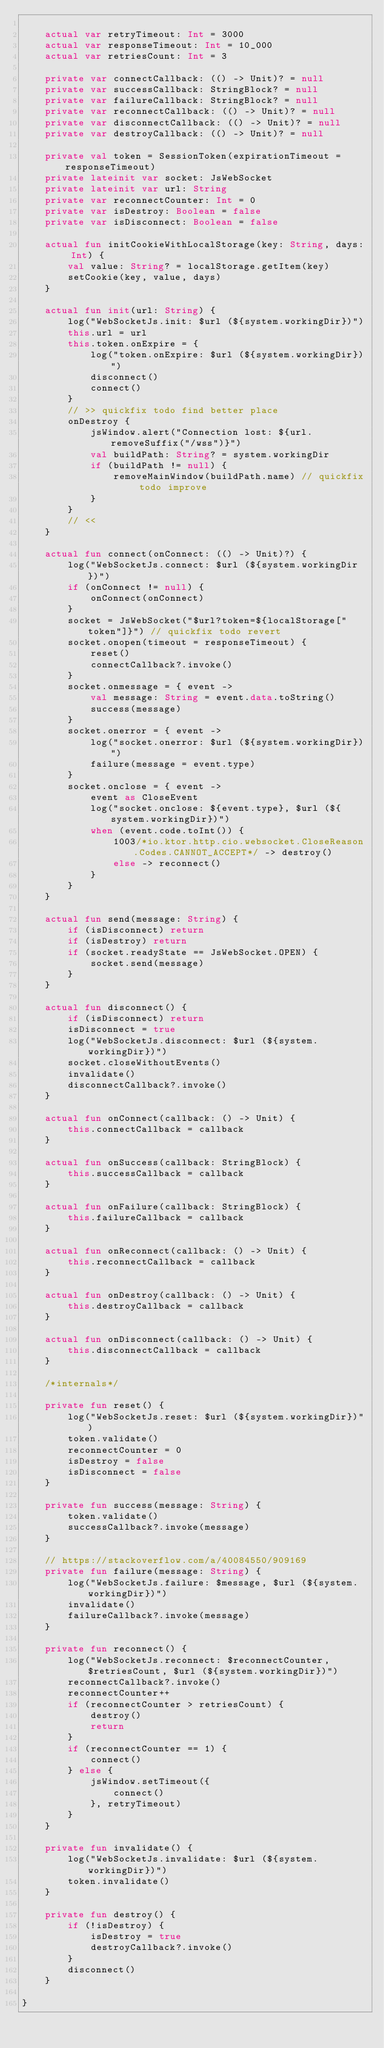<code> <loc_0><loc_0><loc_500><loc_500><_Kotlin_>
    actual var retryTimeout: Int = 3000
    actual var responseTimeout: Int = 10_000
    actual var retriesCount: Int = 3

    private var connectCallback: (() -> Unit)? = null
    private var successCallback: StringBlock? = null
    private var failureCallback: StringBlock? = null
    private var reconnectCallback: (() -> Unit)? = null
    private var disconnectCallback: (() -> Unit)? = null
    private var destroyCallback: (() -> Unit)? = null

    private val token = SessionToken(expirationTimeout = responseTimeout)
    private lateinit var socket: JsWebSocket
    private lateinit var url: String
    private var reconnectCounter: Int = 0
    private var isDestroy: Boolean = false
    private var isDisconnect: Boolean = false

    actual fun initCookieWithLocalStorage(key: String, days: Int) {
        val value: String? = localStorage.getItem(key)
        setCookie(key, value, days)
    }

    actual fun init(url: String) {
        log("WebSocketJs.init: $url (${system.workingDir})")
        this.url = url
        this.token.onExpire = {
            log("token.onExpire: $url (${system.workingDir})")
            disconnect()
            connect()
        }
        // >> quickfix todo find better place
        onDestroy {
            jsWindow.alert("Connection lost: ${url.removeSuffix("/wss")}")
            val buildPath: String? = system.workingDir
            if (buildPath != null) {
                removeMainWindow(buildPath.name) // quickfix todo improve
            }
        }
        // <<
    }

    actual fun connect(onConnect: (() -> Unit)?) {
        log("WebSocketJs.connect: $url (${system.workingDir})")
        if (onConnect != null) {
            onConnect(onConnect)
        }
        socket = JsWebSocket("$url?token=${localStorage["token"]}") // quickfix todo revert
        socket.onopen(timeout = responseTimeout) {
            reset()
            connectCallback?.invoke()
        }
        socket.onmessage = { event ->
            val message: String = event.data.toString()
            success(message)
        }
        socket.onerror = { event ->
            log("socket.onerror: $url (${system.workingDir})")
            failure(message = event.type)
        }
        socket.onclose = { event ->
            event as CloseEvent
            log("socket.onclose: ${event.type}, $url (${system.workingDir})")
            when (event.code.toInt()) {
                1003/*io.ktor.http.cio.websocket.CloseReason.Codes.CANNOT_ACCEPT*/ -> destroy()
                else -> reconnect()
            }
        }
    }

    actual fun send(message: String) {
        if (isDisconnect) return
        if (isDestroy) return
        if (socket.readyState == JsWebSocket.OPEN) {
            socket.send(message)
        }
    }

    actual fun disconnect() {
        if (isDisconnect) return
        isDisconnect = true
        log("WebSocketJs.disconnect: $url (${system.workingDir})")
        socket.closeWithoutEvents()
        invalidate()
        disconnectCallback?.invoke()
    }

    actual fun onConnect(callback: () -> Unit) {
        this.connectCallback = callback
    }

    actual fun onSuccess(callback: StringBlock) {
        this.successCallback = callback
    }

    actual fun onFailure(callback: StringBlock) {
        this.failureCallback = callback
    }

    actual fun onReconnect(callback: () -> Unit) {
        this.reconnectCallback = callback
    }

    actual fun onDestroy(callback: () -> Unit) {
        this.destroyCallback = callback
    }

    actual fun onDisconnect(callback: () -> Unit) {
        this.disconnectCallback = callback
    }

    /*internals*/

    private fun reset() {
        log("WebSocketJs.reset: $url (${system.workingDir})")
        token.validate()
        reconnectCounter = 0
        isDestroy = false
        isDisconnect = false
    }

    private fun success(message: String) {
        token.validate()
        successCallback?.invoke(message)
    }

    // https://stackoverflow.com/a/40084550/909169
    private fun failure(message: String) {
        log("WebSocketJs.failure: $message, $url (${system.workingDir})")
        invalidate()
        failureCallback?.invoke(message)
    }

    private fun reconnect() {
        log("WebSocketJs.reconnect: $reconnectCounter, $retriesCount, $url (${system.workingDir})")
        reconnectCallback?.invoke()
        reconnectCounter++
        if (reconnectCounter > retriesCount) {
            destroy()
            return
        }
        if (reconnectCounter == 1) {
            connect()
        } else {
            jsWindow.setTimeout({
                connect()
            }, retryTimeout)
        }
    }

    private fun invalidate() {
        log("WebSocketJs.invalidate: $url (${system.workingDir})")
        token.invalidate()
    }

    private fun destroy() {
        if (!isDestroy) {
            isDestroy = true
            destroyCallback?.invoke()
        }
        disconnect()
    }

}
</code> 